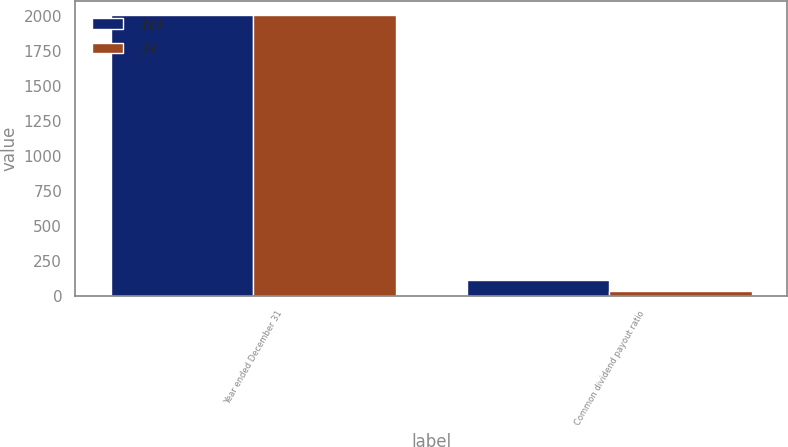Convert chart. <chart><loc_0><loc_0><loc_500><loc_500><stacked_bar_chart><ecel><fcel>Year ended December 31<fcel>Common dividend payout ratio<nl><fcel>114<fcel>2008<fcel>114<nl><fcel>34<fcel>2007<fcel>34<nl></chart> 